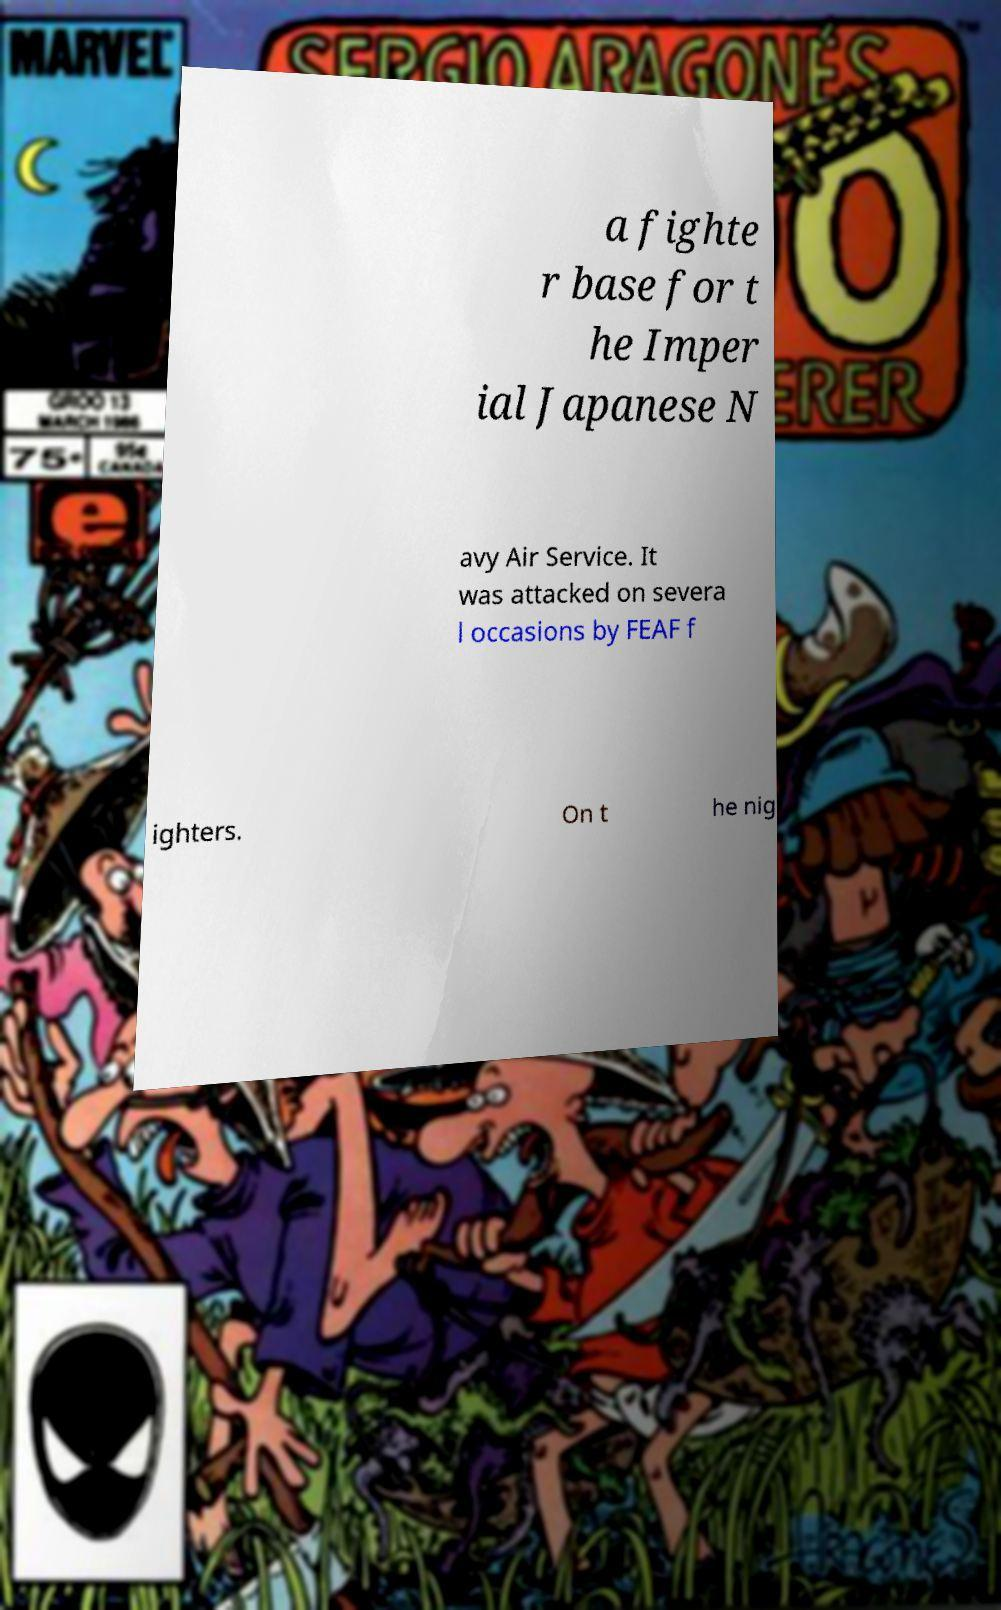Please identify and transcribe the text found in this image. a fighte r base for t he Imper ial Japanese N avy Air Service. It was attacked on severa l occasions by FEAF f ighters. On t he nig 